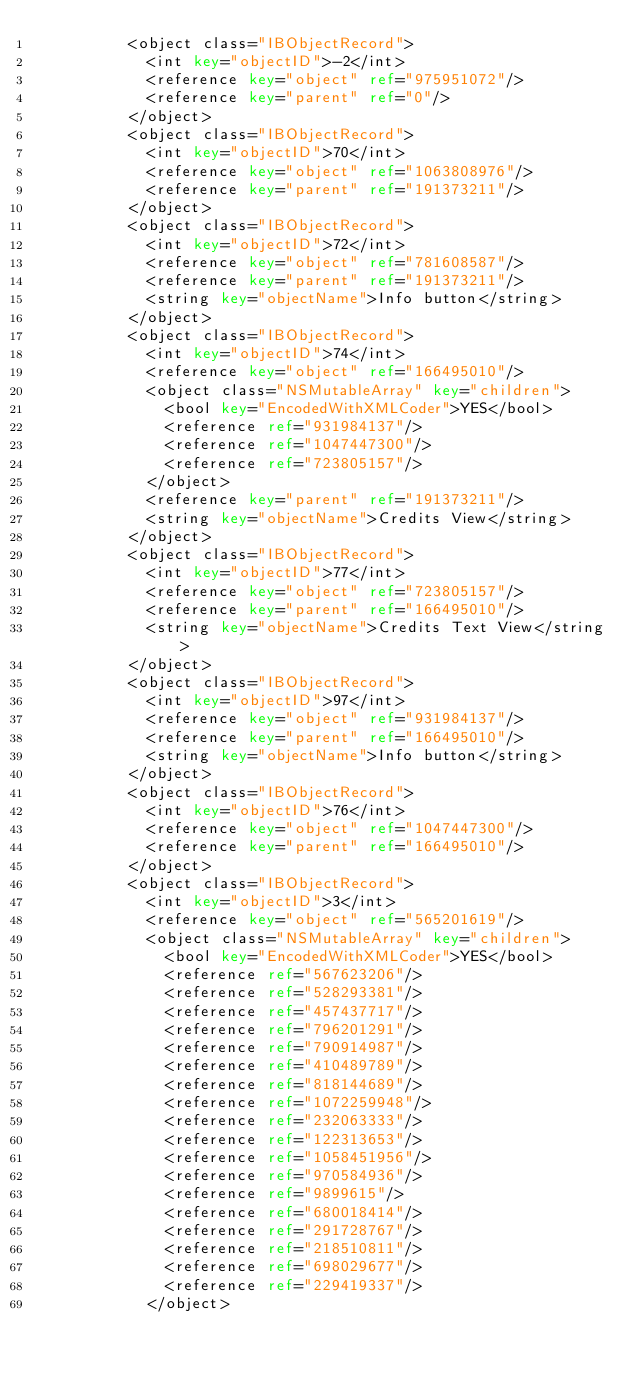<code> <loc_0><loc_0><loc_500><loc_500><_XML_>					<object class="IBObjectRecord">
						<int key="objectID">-2</int>
						<reference key="object" ref="975951072"/>
						<reference key="parent" ref="0"/>
					</object>
					<object class="IBObjectRecord">
						<int key="objectID">70</int>
						<reference key="object" ref="1063808976"/>
						<reference key="parent" ref="191373211"/>
					</object>
					<object class="IBObjectRecord">
						<int key="objectID">72</int>
						<reference key="object" ref="781608587"/>
						<reference key="parent" ref="191373211"/>
						<string key="objectName">Info button</string>
					</object>
					<object class="IBObjectRecord">
						<int key="objectID">74</int>
						<reference key="object" ref="166495010"/>
						<object class="NSMutableArray" key="children">
							<bool key="EncodedWithXMLCoder">YES</bool>
							<reference ref="931984137"/>
							<reference ref="1047447300"/>
							<reference ref="723805157"/>
						</object>
						<reference key="parent" ref="191373211"/>
						<string key="objectName">Credits View</string>
					</object>
					<object class="IBObjectRecord">
						<int key="objectID">77</int>
						<reference key="object" ref="723805157"/>
						<reference key="parent" ref="166495010"/>
						<string key="objectName">Credits Text View</string>
					</object>
					<object class="IBObjectRecord">
						<int key="objectID">97</int>
						<reference key="object" ref="931984137"/>
						<reference key="parent" ref="166495010"/>
						<string key="objectName">Info button</string>
					</object>
					<object class="IBObjectRecord">
						<int key="objectID">76</int>
						<reference key="object" ref="1047447300"/>
						<reference key="parent" ref="166495010"/>
					</object>
					<object class="IBObjectRecord">
						<int key="objectID">3</int>
						<reference key="object" ref="565201619"/>
						<object class="NSMutableArray" key="children">
							<bool key="EncodedWithXMLCoder">YES</bool>
							<reference ref="567623206"/>
							<reference ref="528293381"/>
							<reference ref="457437717"/>
							<reference ref="796201291"/>
							<reference ref="790914987"/>
							<reference ref="410489789"/>
							<reference ref="818144689"/>
							<reference ref="1072259948"/>
							<reference ref="232063333"/>
							<reference ref="122313653"/>
							<reference ref="1058451956"/>
							<reference ref="970584936"/>
							<reference ref="9899615"/>
							<reference ref="680018414"/>
							<reference ref="291728767"/>
							<reference ref="218510811"/>
							<reference ref="698029677"/>
							<reference ref="229419337"/>
						</object></code> 